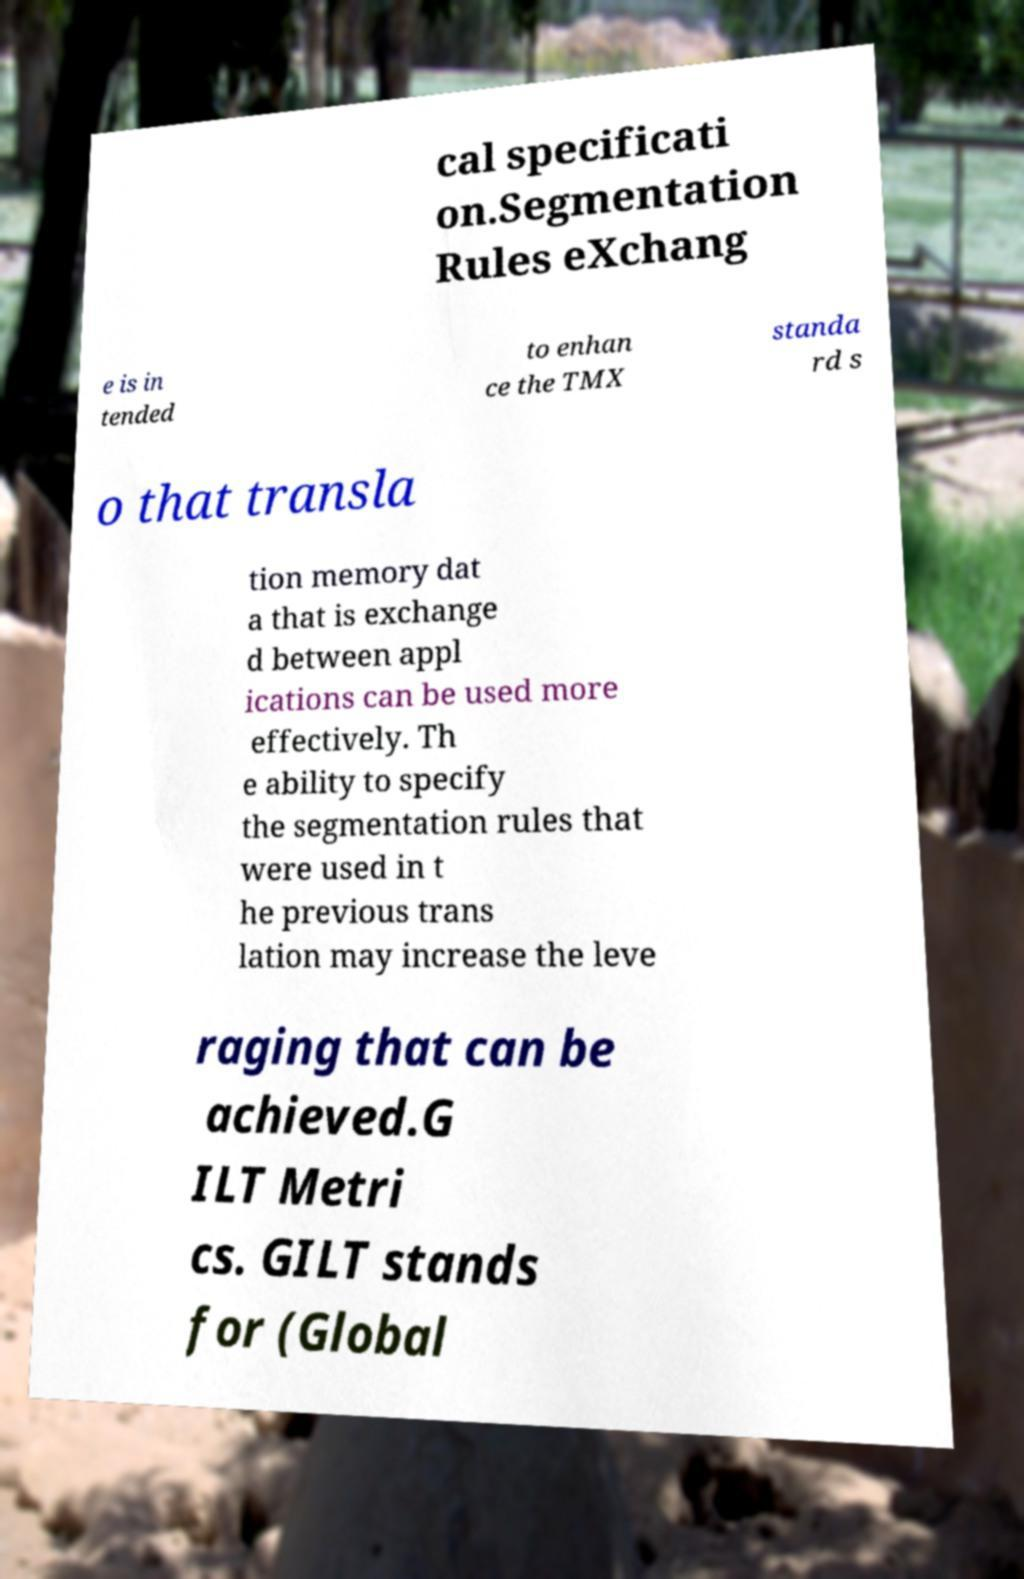Please identify and transcribe the text found in this image. cal specificati on.Segmentation Rules eXchang e is in tended to enhan ce the TMX standa rd s o that transla tion memory dat a that is exchange d between appl ications can be used more effectively. Th e ability to specify the segmentation rules that were used in t he previous trans lation may increase the leve raging that can be achieved.G ILT Metri cs. GILT stands for (Global 